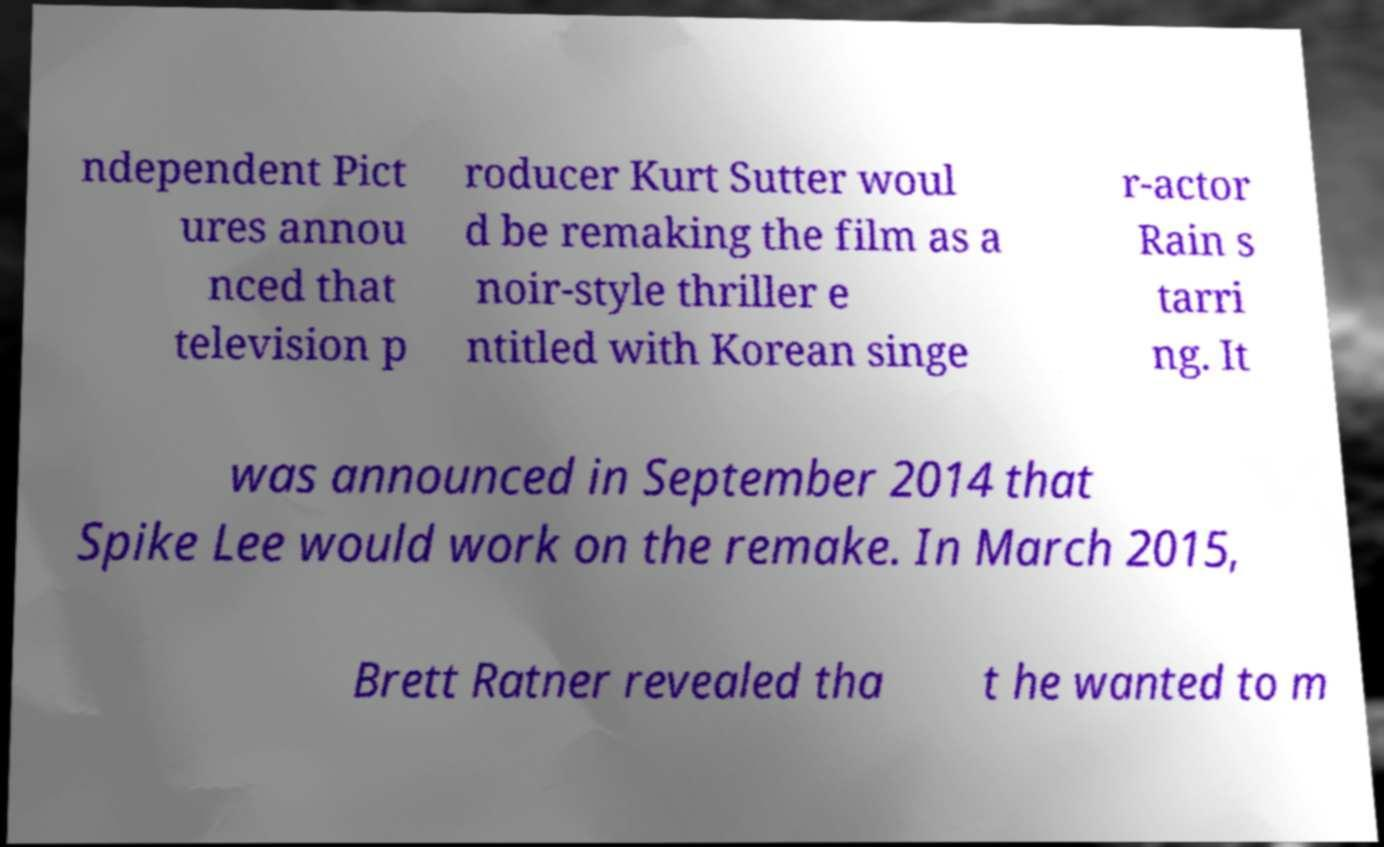I need the written content from this picture converted into text. Can you do that? ndependent Pict ures annou nced that television p roducer Kurt Sutter woul d be remaking the film as a noir-style thriller e ntitled with Korean singe r-actor Rain s tarri ng. It was announced in September 2014 that Spike Lee would work on the remake. In March 2015, Brett Ratner revealed tha t he wanted to m 